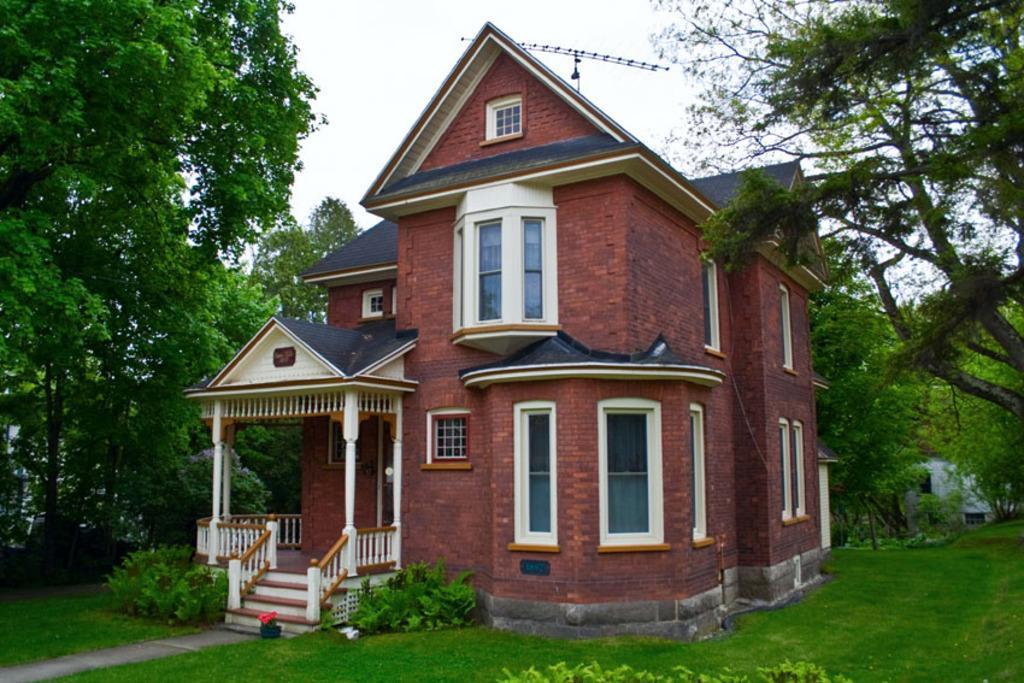In one or two sentences, can you explain what this image depicts? In this image I can see a house and number of trees. I can also see open ground with grass on it. 